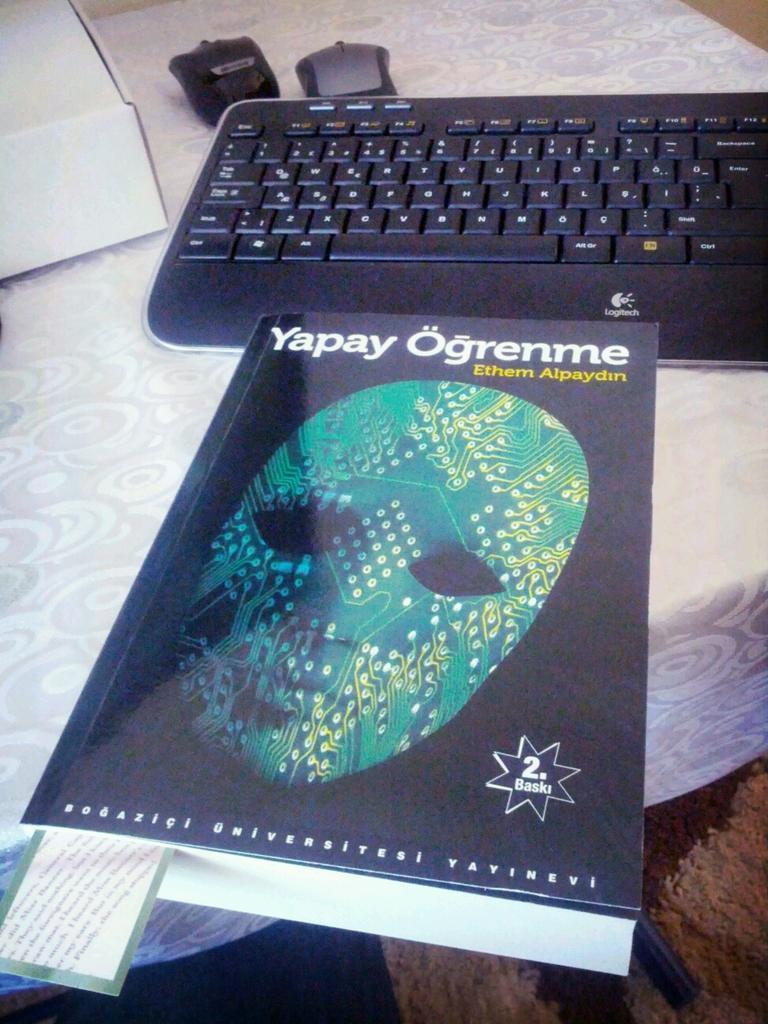Can you describe this image briefly? Here in this picture we can see a table, on which we can see a key board, a couple of mouses and a book, on which we can see a mask picture present on it over there. 